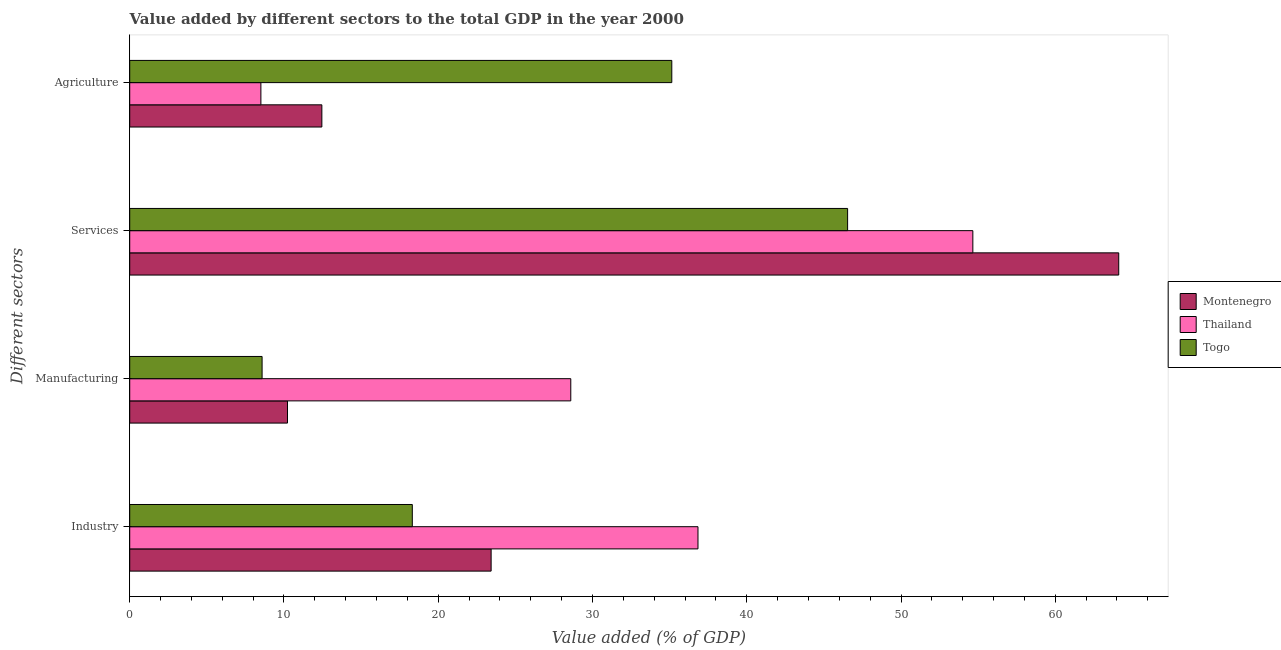How many different coloured bars are there?
Provide a succinct answer. 3. Are the number of bars per tick equal to the number of legend labels?
Your response must be concise. Yes. Are the number of bars on each tick of the Y-axis equal?
Ensure brevity in your answer.  Yes. How many bars are there on the 3rd tick from the top?
Your response must be concise. 3. How many bars are there on the 4th tick from the bottom?
Your response must be concise. 3. What is the label of the 4th group of bars from the top?
Offer a terse response. Industry. What is the value added by services sector in Montenegro?
Your response must be concise. 64.12. Across all countries, what is the maximum value added by agricultural sector?
Keep it short and to the point. 35.14. Across all countries, what is the minimum value added by industrial sector?
Provide a succinct answer. 18.32. In which country was the value added by manufacturing sector maximum?
Provide a short and direct response. Thailand. In which country was the value added by industrial sector minimum?
Make the answer very short. Togo. What is the total value added by manufacturing sector in the graph?
Your response must be concise. 47.4. What is the difference between the value added by services sector in Thailand and that in Montenegro?
Offer a terse response. -9.46. What is the difference between the value added by manufacturing sector in Togo and the value added by services sector in Thailand?
Offer a very short reply. -46.08. What is the average value added by industrial sector per country?
Your response must be concise. 26.2. What is the difference between the value added by agricultural sector and value added by industrial sector in Togo?
Make the answer very short. 16.82. What is the ratio of the value added by services sector in Montenegro to that in Togo?
Ensure brevity in your answer.  1.38. Is the difference between the value added by manufacturing sector in Montenegro and Togo greater than the difference between the value added by industrial sector in Montenegro and Togo?
Make the answer very short. No. What is the difference between the highest and the second highest value added by industrial sector?
Keep it short and to the point. 13.41. What is the difference between the highest and the lowest value added by services sector?
Your response must be concise. 17.58. Is the sum of the value added by agricultural sector in Thailand and Togo greater than the maximum value added by manufacturing sector across all countries?
Your answer should be compact. Yes. Is it the case that in every country, the sum of the value added by services sector and value added by agricultural sector is greater than the sum of value added by manufacturing sector and value added by industrial sector?
Offer a very short reply. Yes. What does the 1st bar from the top in Industry represents?
Your answer should be compact. Togo. What does the 3rd bar from the bottom in Industry represents?
Offer a terse response. Togo. Is it the case that in every country, the sum of the value added by industrial sector and value added by manufacturing sector is greater than the value added by services sector?
Provide a succinct answer. No. How many bars are there?
Make the answer very short. 12. Does the graph contain any zero values?
Give a very brief answer. No. Does the graph contain grids?
Ensure brevity in your answer.  No. Where does the legend appear in the graph?
Your response must be concise. Center right. How many legend labels are there?
Make the answer very short. 3. What is the title of the graph?
Your answer should be compact. Value added by different sectors to the total GDP in the year 2000. What is the label or title of the X-axis?
Offer a terse response. Value added (% of GDP). What is the label or title of the Y-axis?
Keep it short and to the point. Different sectors. What is the Value added (% of GDP) in Montenegro in Industry?
Your answer should be compact. 23.43. What is the Value added (% of GDP) of Thailand in Industry?
Give a very brief answer. 36.84. What is the Value added (% of GDP) in Togo in Industry?
Your answer should be very brief. 18.32. What is the Value added (% of GDP) in Montenegro in Manufacturing?
Provide a short and direct response. 10.23. What is the Value added (% of GDP) of Thailand in Manufacturing?
Your answer should be very brief. 28.59. What is the Value added (% of GDP) of Togo in Manufacturing?
Keep it short and to the point. 8.58. What is the Value added (% of GDP) of Montenegro in Services?
Keep it short and to the point. 64.12. What is the Value added (% of GDP) in Thailand in Services?
Give a very brief answer. 54.66. What is the Value added (% of GDP) of Togo in Services?
Your answer should be compact. 46.54. What is the Value added (% of GDP) in Montenegro in Agriculture?
Keep it short and to the point. 12.46. What is the Value added (% of GDP) of Thailand in Agriculture?
Provide a short and direct response. 8.5. What is the Value added (% of GDP) of Togo in Agriculture?
Make the answer very short. 35.14. Across all Different sectors, what is the maximum Value added (% of GDP) in Montenegro?
Make the answer very short. 64.12. Across all Different sectors, what is the maximum Value added (% of GDP) in Thailand?
Your response must be concise. 54.66. Across all Different sectors, what is the maximum Value added (% of GDP) of Togo?
Ensure brevity in your answer.  46.54. Across all Different sectors, what is the minimum Value added (% of GDP) in Montenegro?
Your answer should be compact. 10.23. Across all Different sectors, what is the minimum Value added (% of GDP) in Thailand?
Give a very brief answer. 8.5. Across all Different sectors, what is the minimum Value added (% of GDP) in Togo?
Your answer should be compact. 8.58. What is the total Value added (% of GDP) of Montenegro in the graph?
Provide a succinct answer. 110.23. What is the total Value added (% of GDP) of Thailand in the graph?
Give a very brief answer. 128.59. What is the total Value added (% of GDP) in Togo in the graph?
Offer a terse response. 108.58. What is the difference between the Value added (% of GDP) of Montenegro in Industry and that in Manufacturing?
Make the answer very short. 13.2. What is the difference between the Value added (% of GDP) of Thailand in Industry and that in Manufacturing?
Your answer should be compact. 8.25. What is the difference between the Value added (% of GDP) of Togo in Industry and that in Manufacturing?
Provide a short and direct response. 9.74. What is the difference between the Value added (% of GDP) of Montenegro in Industry and that in Services?
Keep it short and to the point. -40.69. What is the difference between the Value added (% of GDP) in Thailand in Industry and that in Services?
Ensure brevity in your answer.  -17.82. What is the difference between the Value added (% of GDP) in Togo in Industry and that in Services?
Your answer should be compact. -28.22. What is the difference between the Value added (% of GDP) of Montenegro in Industry and that in Agriculture?
Your response must be concise. 10.97. What is the difference between the Value added (% of GDP) in Thailand in Industry and that in Agriculture?
Your response must be concise. 28.34. What is the difference between the Value added (% of GDP) in Togo in Industry and that in Agriculture?
Offer a terse response. -16.82. What is the difference between the Value added (% of GDP) in Montenegro in Manufacturing and that in Services?
Your response must be concise. -53.89. What is the difference between the Value added (% of GDP) in Thailand in Manufacturing and that in Services?
Your answer should be very brief. -26.06. What is the difference between the Value added (% of GDP) in Togo in Manufacturing and that in Services?
Offer a very short reply. -37.96. What is the difference between the Value added (% of GDP) in Montenegro in Manufacturing and that in Agriculture?
Provide a short and direct response. -2.23. What is the difference between the Value added (% of GDP) in Thailand in Manufacturing and that in Agriculture?
Provide a short and direct response. 20.09. What is the difference between the Value added (% of GDP) of Togo in Manufacturing and that in Agriculture?
Your response must be concise. -26.56. What is the difference between the Value added (% of GDP) of Montenegro in Services and that in Agriculture?
Make the answer very short. 51.66. What is the difference between the Value added (% of GDP) in Thailand in Services and that in Agriculture?
Offer a very short reply. 46.15. What is the difference between the Value added (% of GDP) of Togo in Services and that in Agriculture?
Make the answer very short. 11.4. What is the difference between the Value added (% of GDP) in Montenegro in Industry and the Value added (% of GDP) in Thailand in Manufacturing?
Offer a terse response. -5.16. What is the difference between the Value added (% of GDP) in Montenegro in Industry and the Value added (% of GDP) in Togo in Manufacturing?
Your response must be concise. 14.85. What is the difference between the Value added (% of GDP) in Thailand in Industry and the Value added (% of GDP) in Togo in Manufacturing?
Ensure brevity in your answer.  28.26. What is the difference between the Value added (% of GDP) of Montenegro in Industry and the Value added (% of GDP) of Thailand in Services?
Make the answer very short. -31.23. What is the difference between the Value added (% of GDP) of Montenegro in Industry and the Value added (% of GDP) of Togo in Services?
Ensure brevity in your answer.  -23.11. What is the difference between the Value added (% of GDP) in Thailand in Industry and the Value added (% of GDP) in Togo in Services?
Give a very brief answer. -9.7. What is the difference between the Value added (% of GDP) in Montenegro in Industry and the Value added (% of GDP) in Thailand in Agriculture?
Ensure brevity in your answer.  14.93. What is the difference between the Value added (% of GDP) in Montenegro in Industry and the Value added (% of GDP) in Togo in Agriculture?
Provide a succinct answer. -11.71. What is the difference between the Value added (% of GDP) in Thailand in Industry and the Value added (% of GDP) in Togo in Agriculture?
Offer a very short reply. 1.7. What is the difference between the Value added (% of GDP) of Montenegro in Manufacturing and the Value added (% of GDP) of Thailand in Services?
Your response must be concise. -44.43. What is the difference between the Value added (% of GDP) of Montenegro in Manufacturing and the Value added (% of GDP) of Togo in Services?
Your answer should be very brief. -36.31. What is the difference between the Value added (% of GDP) in Thailand in Manufacturing and the Value added (% of GDP) in Togo in Services?
Your answer should be compact. -17.95. What is the difference between the Value added (% of GDP) of Montenegro in Manufacturing and the Value added (% of GDP) of Thailand in Agriculture?
Give a very brief answer. 1.73. What is the difference between the Value added (% of GDP) in Montenegro in Manufacturing and the Value added (% of GDP) in Togo in Agriculture?
Your response must be concise. -24.91. What is the difference between the Value added (% of GDP) in Thailand in Manufacturing and the Value added (% of GDP) in Togo in Agriculture?
Your answer should be compact. -6.55. What is the difference between the Value added (% of GDP) of Montenegro in Services and the Value added (% of GDP) of Thailand in Agriculture?
Your answer should be compact. 55.61. What is the difference between the Value added (% of GDP) of Montenegro in Services and the Value added (% of GDP) of Togo in Agriculture?
Keep it short and to the point. 28.97. What is the difference between the Value added (% of GDP) in Thailand in Services and the Value added (% of GDP) in Togo in Agriculture?
Your answer should be compact. 19.52. What is the average Value added (% of GDP) of Montenegro per Different sectors?
Keep it short and to the point. 27.56. What is the average Value added (% of GDP) in Thailand per Different sectors?
Provide a short and direct response. 32.15. What is the average Value added (% of GDP) of Togo per Different sectors?
Your answer should be very brief. 27.15. What is the difference between the Value added (% of GDP) of Montenegro and Value added (% of GDP) of Thailand in Industry?
Offer a very short reply. -13.41. What is the difference between the Value added (% of GDP) in Montenegro and Value added (% of GDP) in Togo in Industry?
Make the answer very short. 5.11. What is the difference between the Value added (% of GDP) of Thailand and Value added (% of GDP) of Togo in Industry?
Ensure brevity in your answer.  18.52. What is the difference between the Value added (% of GDP) in Montenegro and Value added (% of GDP) in Thailand in Manufacturing?
Your answer should be compact. -18.36. What is the difference between the Value added (% of GDP) of Montenegro and Value added (% of GDP) of Togo in Manufacturing?
Provide a succinct answer. 1.65. What is the difference between the Value added (% of GDP) in Thailand and Value added (% of GDP) in Togo in Manufacturing?
Offer a very short reply. 20.01. What is the difference between the Value added (% of GDP) of Montenegro and Value added (% of GDP) of Thailand in Services?
Your answer should be compact. 9.46. What is the difference between the Value added (% of GDP) in Montenegro and Value added (% of GDP) in Togo in Services?
Provide a succinct answer. 17.58. What is the difference between the Value added (% of GDP) in Thailand and Value added (% of GDP) in Togo in Services?
Ensure brevity in your answer.  8.12. What is the difference between the Value added (% of GDP) in Montenegro and Value added (% of GDP) in Thailand in Agriculture?
Provide a succinct answer. 3.95. What is the difference between the Value added (% of GDP) of Montenegro and Value added (% of GDP) of Togo in Agriculture?
Provide a short and direct response. -22.69. What is the difference between the Value added (% of GDP) of Thailand and Value added (% of GDP) of Togo in Agriculture?
Keep it short and to the point. -26.64. What is the ratio of the Value added (% of GDP) in Montenegro in Industry to that in Manufacturing?
Ensure brevity in your answer.  2.29. What is the ratio of the Value added (% of GDP) of Thailand in Industry to that in Manufacturing?
Provide a succinct answer. 1.29. What is the ratio of the Value added (% of GDP) in Togo in Industry to that in Manufacturing?
Ensure brevity in your answer.  2.13. What is the ratio of the Value added (% of GDP) of Montenegro in Industry to that in Services?
Your response must be concise. 0.37. What is the ratio of the Value added (% of GDP) in Thailand in Industry to that in Services?
Ensure brevity in your answer.  0.67. What is the ratio of the Value added (% of GDP) of Togo in Industry to that in Services?
Your response must be concise. 0.39. What is the ratio of the Value added (% of GDP) in Montenegro in Industry to that in Agriculture?
Your response must be concise. 1.88. What is the ratio of the Value added (% of GDP) of Thailand in Industry to that in Agriculture?
Offer a terse response. 4.33. What is the ratio of the Value added (% of GDP) in Togo in Industry to that in Agriculture?
Provide a short and direct response. 0.52. What is the ratio of the Value added (% of GDP) in Montenegro in Manufacturing to that in Services?
Provide a succinct answer. 0.16. What is the ratio of the Value added (% of GDP) in Thailand in Manufacturing to that in Services?
Ensure brevity in your answer.  0.52. What is the ratio of the Value added (% of GDP) in Togo in Manufacturing to that in Services?
Offer a terse response. 0.18. What is the ratio of the Value added (% of GDP) of Montenegro in Manufacturing to that in Agriculture?
Give a very brief answer. 0.82. What is the ratio of the Value added (% of GDP) of Thailand in Manufacturing to that in Agriculture?
Make the answer very short. 3.36. What is the ratio of the Value added (% of GDP) of Togo in Manufacturing to that in Agriculture?
Provide a succinct answer. 0.24. What is the ratio of the Value added (% of GDP) of Montenegro in Services to that in Agriculture?
Your response must be concise. 5.15. What is the ratio of the Value added (% of GDP) in Thailand in Services to that in Agriculture?
Your response must be concise. 6.43. What is the ratio of the Value added (% of GDP) in Togo in Services to that in Agriculture?
Your answer should be compact. 1.32. What is the difference between the highest and the second highest Value added (% of GDP) in Montenegro?
Give a very brief answer. 40.69. What is the difference between the highest and the second highest Value added (% of GDP) in Thailand?
Your answer should be compact. 17.82. What is the difference between the highest and the second highest Value added (% of GDP) of Togo?
Provide a short and direct response. 11.4. What is the difference between the highest and the lowest Value added (% of GDP) of Montenegro?
Your answer should be compact. 53.89. What is the difference between the highest and the lowest Value added (% of GDP) in Thailand?
Give a very brief answer. 46.15. What is the difference between the highest and the lowest Value added (% of GDP) of Togo?
Your answer should be compact. 37.96. 